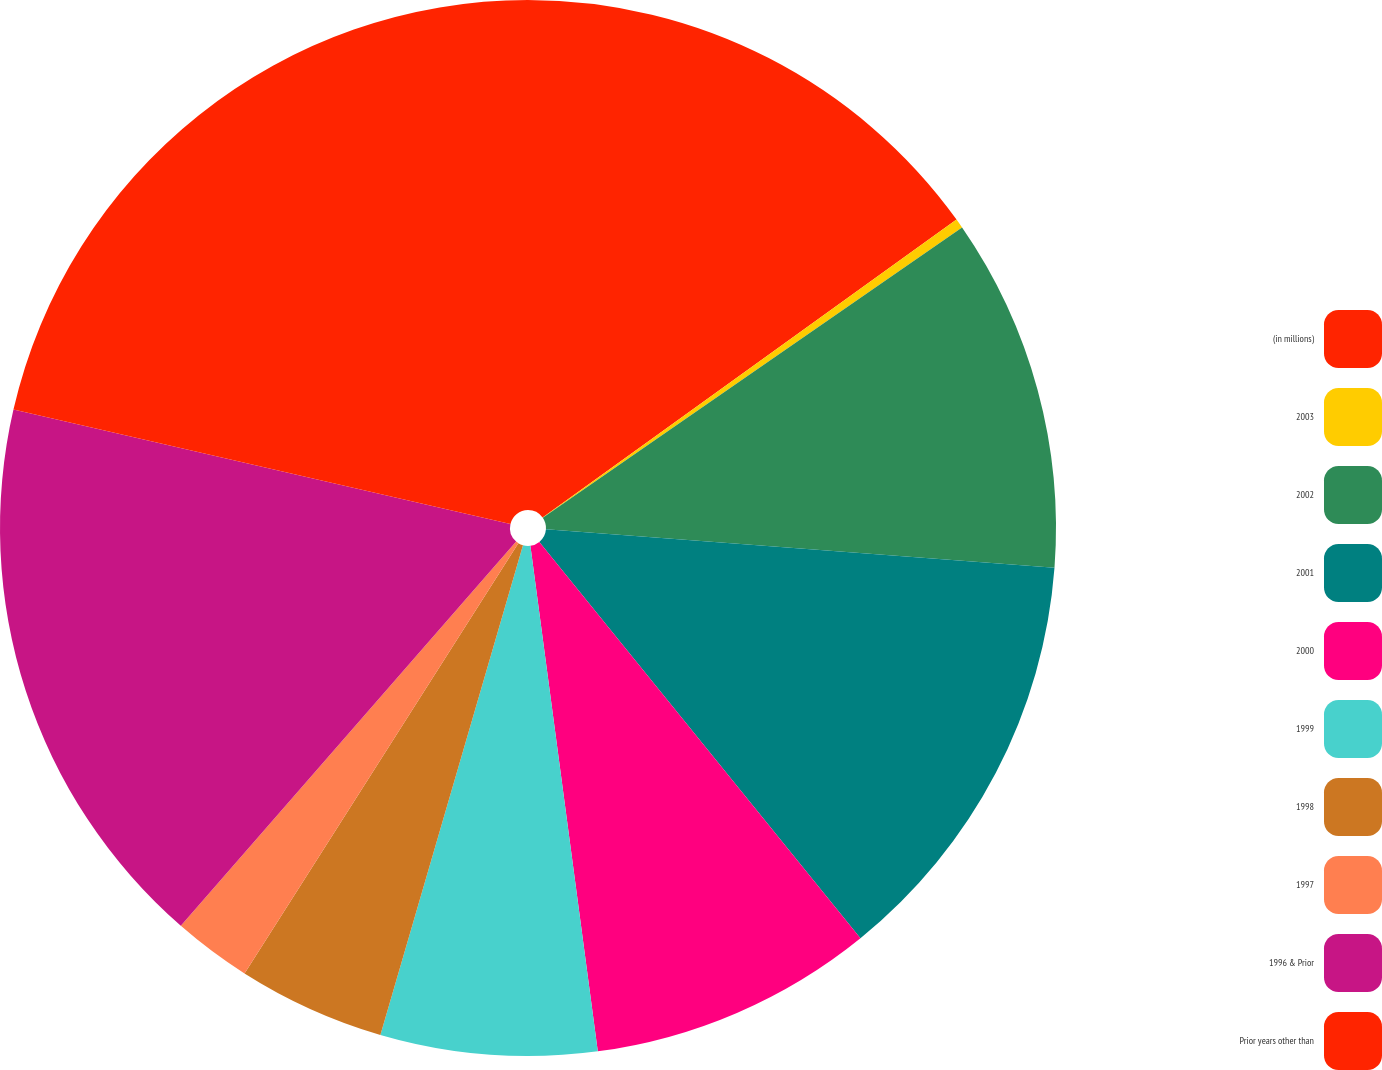Convert chart to OTSL. <chart><loc_0><loc_0><loc_500><loc_500><pie_chart><fcel>(in millions)<fcel>2003<fcel>2002<fcel>2001<fcel>2000<fcel>1999<fcel>1998<fcel>1997<fcel>1996 & Prior<fcel>Prior years other than<nl><fcel>15.07%<fcel>0.29%<fcel>10.84%<fcel>12.96%<fcel>8.73%<fcel>6.62%<fcel>4.51%<fcel>2.4%<fcel>17.18%<fcel>21.4%<nl></chart> 